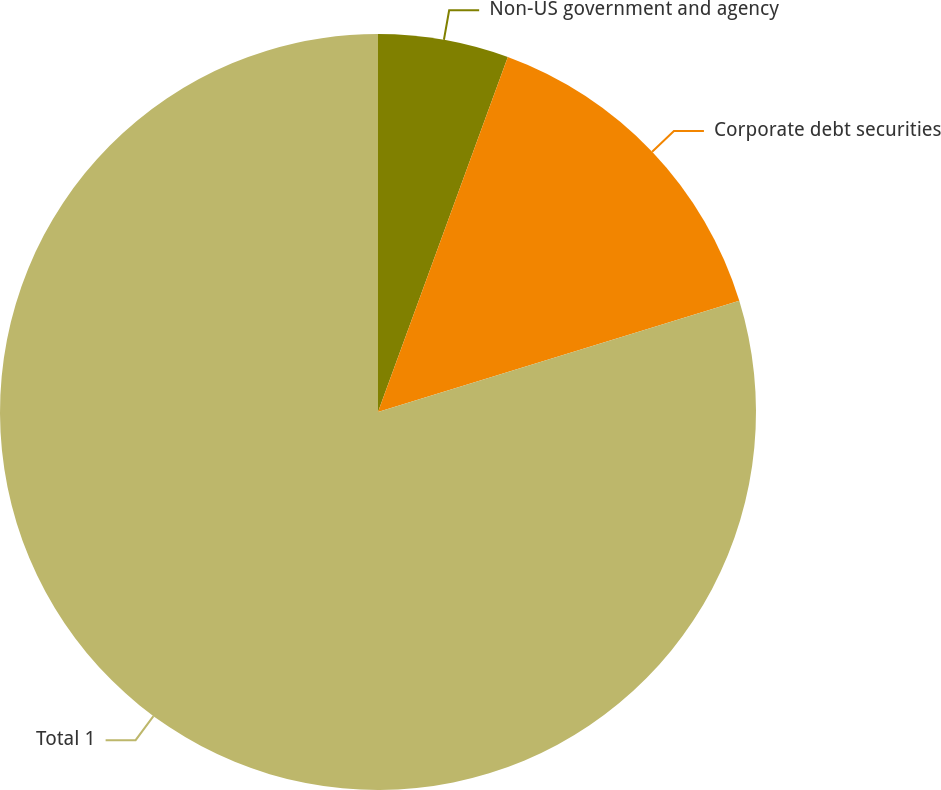Convert chart. <chart><loc_0><loc_0><loc_500><loc_500><pie_chart><fcel>Non-US government and agency<fcel>Corporate debt securities<fcel>Total 1<nl><fcel>5.58%<fcel>14.67%<fcel>79.75%<nl></chart> 